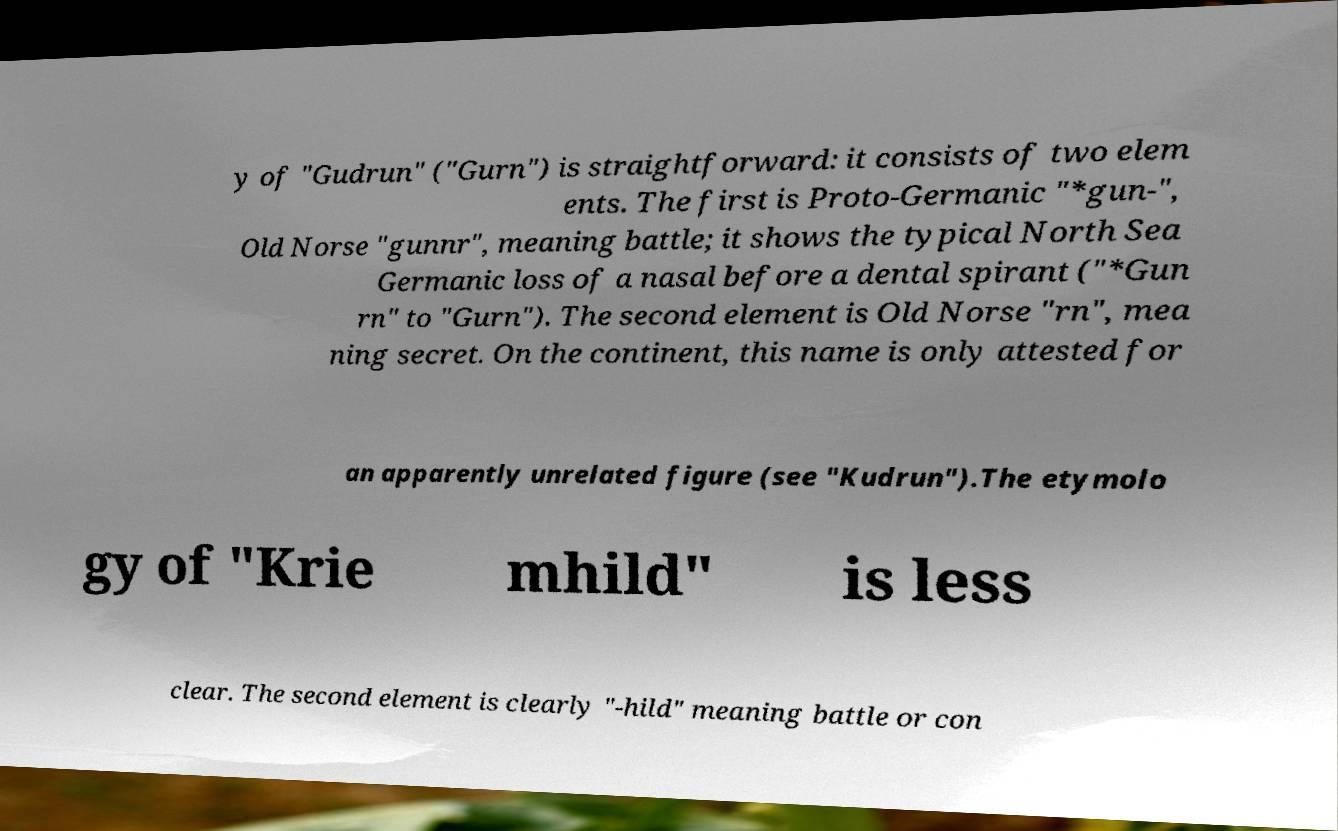Could you extract and type out the text from this image? y of "Gudrun" ("Gurn") is straightforward: it consists of two elem ents. The first is Proto-Germanic "*gun-", Old Norse "gunnr", meaning battle; it shows the typical North Sea Germanic loss of a nasal before a dental spirant ("*Gun rn" to "Gurn"). The second element is Old Norse "rn", mea ning secret. On the continent, this name is only attested for an apparently unrelated figure (see "Kudrun").The etymolo gy of "Krie mhild" is less clear. The second element is clearly "-hild" meaning battle or con 